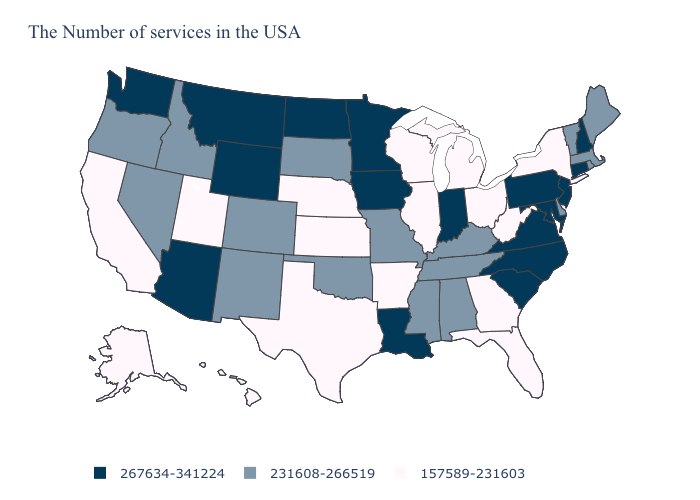Does the first symbol in the legend represent the smallest category?
Short answer required. No. Does the map have missing data?
Concise answer only. No. What is the value of Nebraska?
Concise answer only. 157589-231603. What is the lowest value in the USA?
Short answer required. 157589-231603. Among the states that border New Jersey , does Pennsylvania have the lowest value?
Be succinct. No. Among the states that border Idaho , does Utah have the highest value?
Write a very short answer. No. Which states have the highest value in the USA?
Concise answer only. New Hampshire, Connecticut, New Jersey, Maryland, Pennsylvania, Virginia, North Carolina, South Carolina, Indiana, Louisiana, Minnesota, Iowa, North Dakota, Wyoming, Montana, Arizona, Washington. What is the lowest value in the USA?
Answer briefly. 157589-231603. Among the states that border Oklahoma , which have the lowest value?
Write a very short answer. Arkansas, Kansas, Texas. What is the value of New Mexico?
Be succinct. 231608-266519. Name the states that have a value in the range 231608-266519?
Keep it brief. Maine, Massachusetts, Rhode Island, Vermont, Delaware, Kentucky, Alabama, Tennessee, Mississippi, Missouri, Oklahoma, South Dakota, Colorado, New Mexico, Idaho, Nevada, Oregon. What is the highest value in states that border New York?
Be succinct. 267634-341224. What is the value of Kansas?
Short answer required. 157589-231603. Which states have the lowest value in the USA?
Write a very short answer. New York, West Virginia, Ohio, Florida, Georgia, Michigan, Wisconsin, Illinois, Arkansas, Kansas, Nebraska, Texas, Utah, California, Alaska, Hawaii. What is the value of Massachusetts?
Write a very short answer. 231608-266519. 